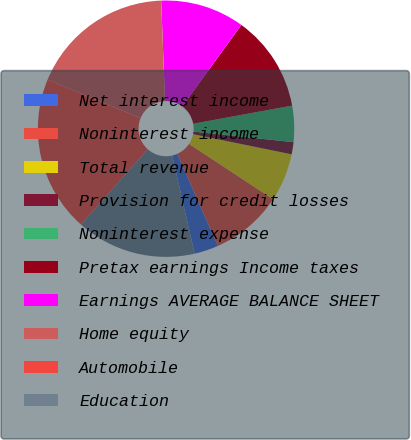<chart> <loc_0><loc_0><loc_500><loc_500><pie_chart><fcel>Net interest income<fcel>Noninterest income<fcel>Total revenue<fcel>Provision for credit losses<fcel>Noninterest expense<fcel>Pretax earnings Income taxes<fcel>Earnings AVERAGE BALANCE SHEET<fcel>Home equity<fcel>Automobile<fcel>Education<nl><fcel>3.05%<fcel>9.09%<fcel>6.07%<fcel>1.53%<fcel>4.56%<fcel>12.12%<fcel>10.6%<fcel>18.16%<fcel>19.68%<fcel>15.14%<nl></chart> 